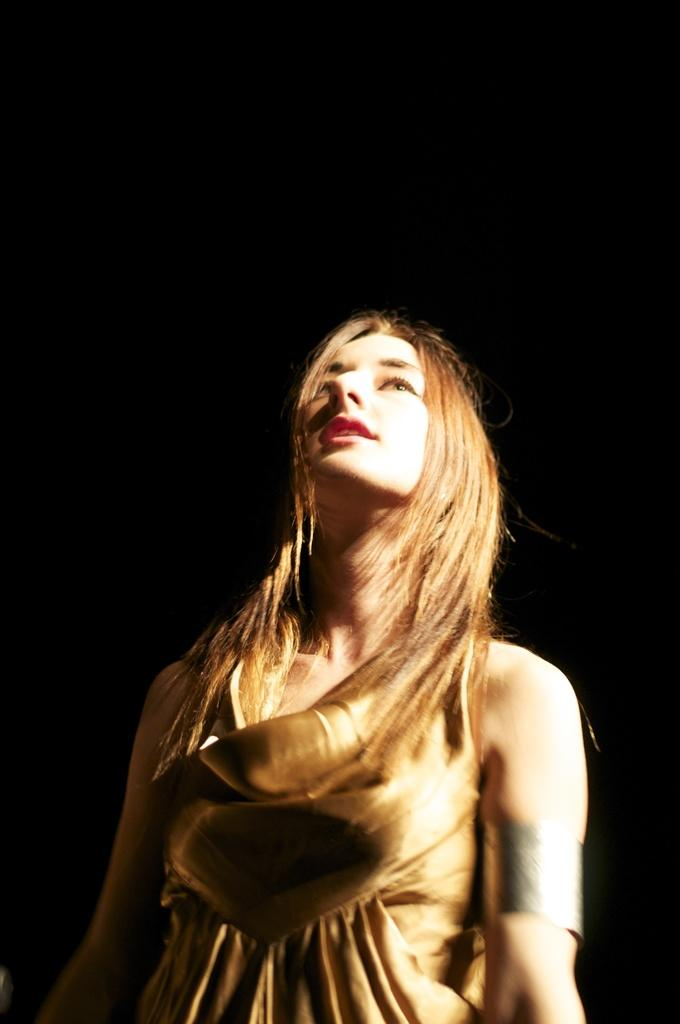Who or what is the main subject in the image? There is a person in the image. What can be observed about the background of the image? The background of the image is dark. What type of apparatus is being used by the person in the image? There is no apparatus visible in the image; only the person and the dark background can be observed. What kind of meal is being prepared by the person in the image? There is no meal preparation visible in the image; the person is the only subject present. 